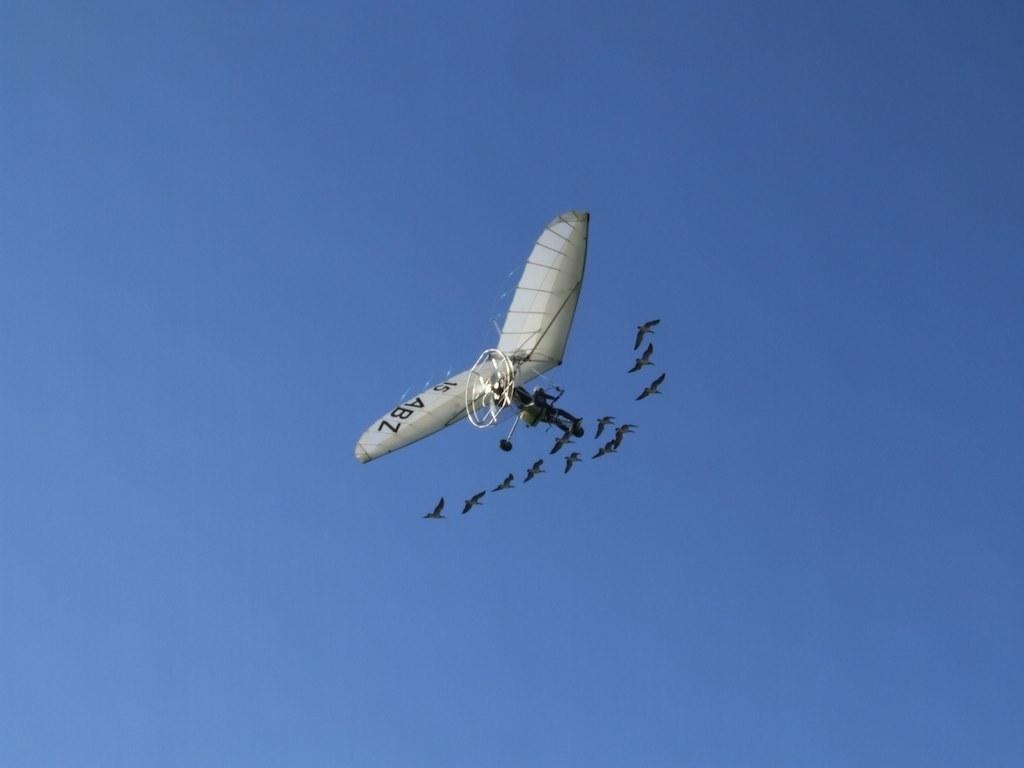Provide a one-sentence caption for the provided image. A single person aircraft with ABZ on its wind is flying with a flock of birds. 